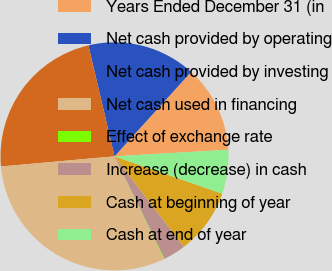Convert chart to OTSL. <chart><loc_0><loc_0><loc_500><loc_500><pie_chart><fcel>Years Ended December 31 (in<fcel>Net cash provided by operating<fcel>Net cash provided by investing<fcel>Net cash used in financing<fcel>Effect of exchange rate<fcel>Increase (decrease) in cash<fcel>Cash at beginning of year<fcel>Cash at end of year<nl><fcel>12.35%<fcel>15.41%<fcel>22.74%<fcel>30.71%<fcel>0.1%<fcel>3.17%<fcel>9.29%<fcel>6.23%<nl></chart> 